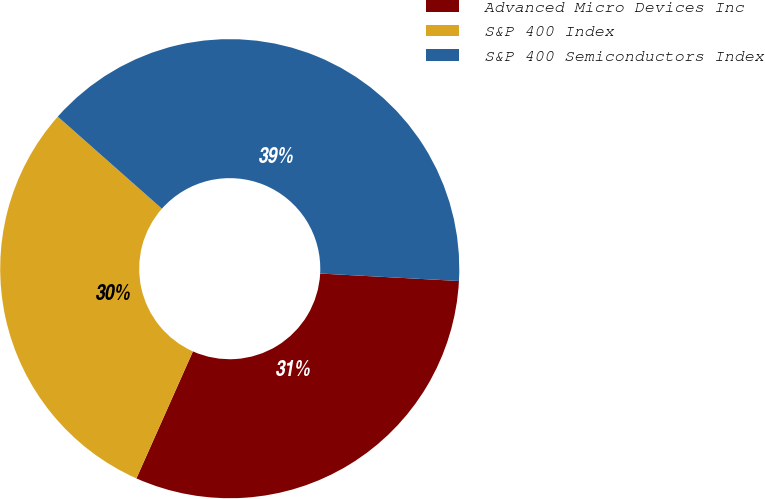<chart> <loc_0><loc_0><loc_500><loc_500><pie_chart><fcel>Advanced Micro Devices Inc<fcel>S&P 400 Index<fcel>S&P 400 Semiconductors Index<nl><fcel>30.81%<fcel>29.86%<fcel>39.33%<nl></chart> 